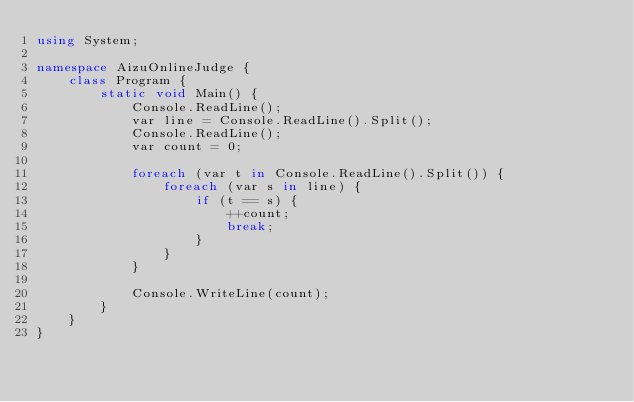<code> <loc_0><loc_0><loc_500><loc_500><_C#_>using System;

namespace AizuOnlineJudge {
    class Program {
        static void Main() {
            Console.ReadLine();
            var line = Console.ReadLine().Split();
            Console.ReadLine();
            var count = 0;

            foreach (var t in Console.ReadLine().Split()) {
                foreach (var s in line) {
                    if (t == s) {
                        ++count;
                        break;
                    }
                }
            }

            Console.WriteLine(count);
        }
    }
}

</code> 